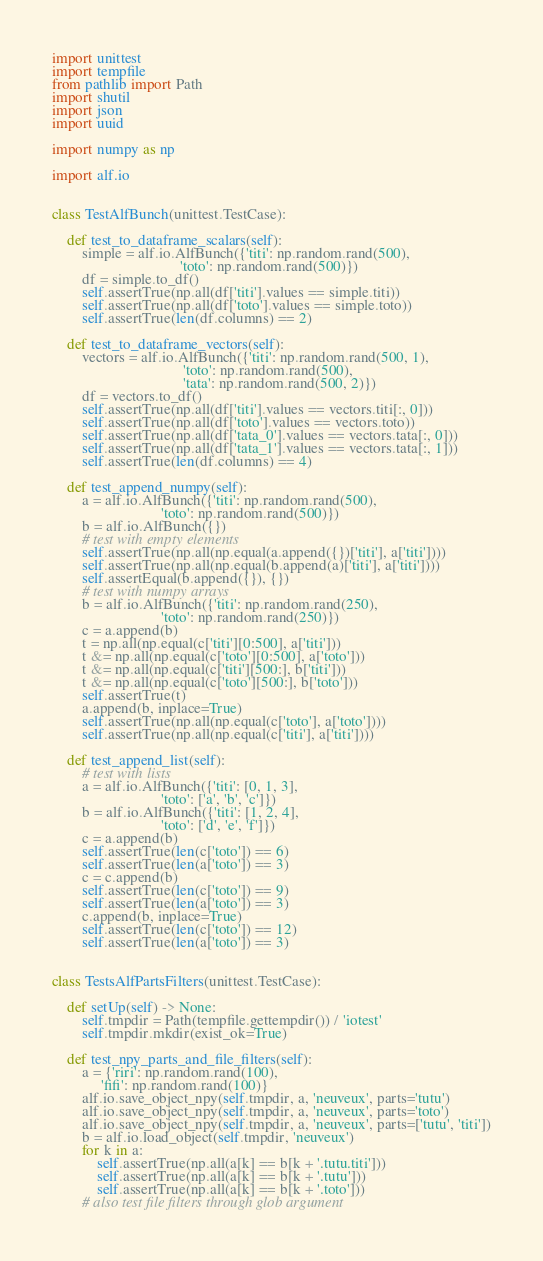<code> <loc_0><loc_0><loc_500><loc_500><_Python_>import unittest
import tempfile
from pathlib import Path
import shutil
import json
import uuid

import numpy as np

import alf.io


class TestAlfBunch(unittest.TestCase):

    def test_to_dataframe_scalars(self):
        simple = alf.io.AlfBunch({'titi': np.random.rand(500),
                                  'toto': np.random.rand(500)})
        df = simple.to_df()
        self.assertTrue(np.all(df['titi'].values == simple.titi))
        self.assertTrue(np.all(df['toto'].values == simple.toto))
        self.assertTrue(len(df.columns) == 2)

    def test_to_dataframe_vectors(self):
        vectors = alf.io.AlfBunch({'titi': np.random.rand(500, 1),
                                   'toto': np.random.rand(500),
                                   'tata': np.random.rand(500, 2)})
        df = vectors.to_df()
        self.assertTrue(np.all(df['titi'].values == vectors.titi[:, 0]))
        self.assertTrue(np.all(df['toto'].values == vectors.toto))
        self.assertTrue(np.all(df['tata_0'].values == vectors.tata[:, 0]))
        self.assertTrue(np.all(df['tata_1'].values == vectors.tata[:, 1]))
        self.assertTrue(len(df.columns) == 4)

    def test_append_numpy(self):
        a = alf.io.AlfBunch({'titi': np.random.rand(500),
                             'toto': np.random.rand(500)})
        b = alf.io.AlfBunch({})
        # test with empty elements
        self.assertTrue(np.all(np.equal(a.append({})['titi'], a['titi'])))
        self.assertTrue(np.all(np.equal(b.append(a)['titi'], a['titi'])))
        self.assertEqual(b.append({}), {})
        # test with numpy arrays
        b = alf.io.AlfBunch({'titi': np.random.rand(250),
                             'toto': np.random.rand(250)})
        c = a.append(b)
        t = np.all(np.equal(c['titi'][0:500], a['titi']))
        t &= np.all(np.equal(c['toto'][0:500], a['toto']))
        t &= np.all(np.equal(c['titi'][500:], b['titi']))
        t &= np.all(np.equal(c['toto'][500:], b['toto']))
        self.assertTrue(t)
        a.append(b, inplace=True)
        self.assertTrue(np.all(np.equal(c['toto'], a['toto'])))
        self.assertTrue(np.all(np.equal(c['titi'], a['titi'])))

    def test_append_list(self):
        # test with lists
        a = alf.io.AlfBunch({'titi': [0, 1, 3],
                             'toto': ['a', 'b', 'c']})
        b = alf.io.AlfBunch({'titi': [1, 2, 4],
                             'toto': ['d', 'e', 'f']})
        c = a.append(b)
        self.assertTrue(len(c['toto']) == 6)
        self.assertTrue(len(a['toto']) == 3)
        c = c.append(b)
        self.assertTrue(len(c['toto']) == 9)
        self.assertTrue(len(a['toto']) == 3)
        c.append(b, inplace=True)
        self.assertTrue(len(c['toto']) == 12)
        self.assertTrue(len(a['toto']) == 3)


class TestsAlfPartsFilters(unittest.TestCase):

    def setUp(self) -> None:
        self.tmpdir = Path(tempfile.gettempdir()) / 'iotest'
        self.tmpdir.mkdir(exist_ok=True)

    def test_npy_parts_and_file_filters(self):
        a = {'riri': np.random.rand(100),
             'fifi': np.random.rand(100)}
        alf.io.save_object_npy(self.tmpdir, a, 'neuveux', parts='tutu')
        alf.io.save_object_npy(self.tmpdir, a, 'neuveux', parts='toto')
        alf.io.save_object_npy(self.tmpdir, a, 'neuveux', parts=['tutu', 'titi'])
        b = alf.io.load_object(self.tmpdir, 'neuveux')
        for k in a:
            self.assertTrue(np.all(a[k] == b[k + '.tutu.titi']))
            self.assertTrue(np.all(a[k] == b[k + '.tutu']))
            self.assertTrue(np.all(a[k] == b[k + '.toto']))
        # also test file filters through glob argument</code> 